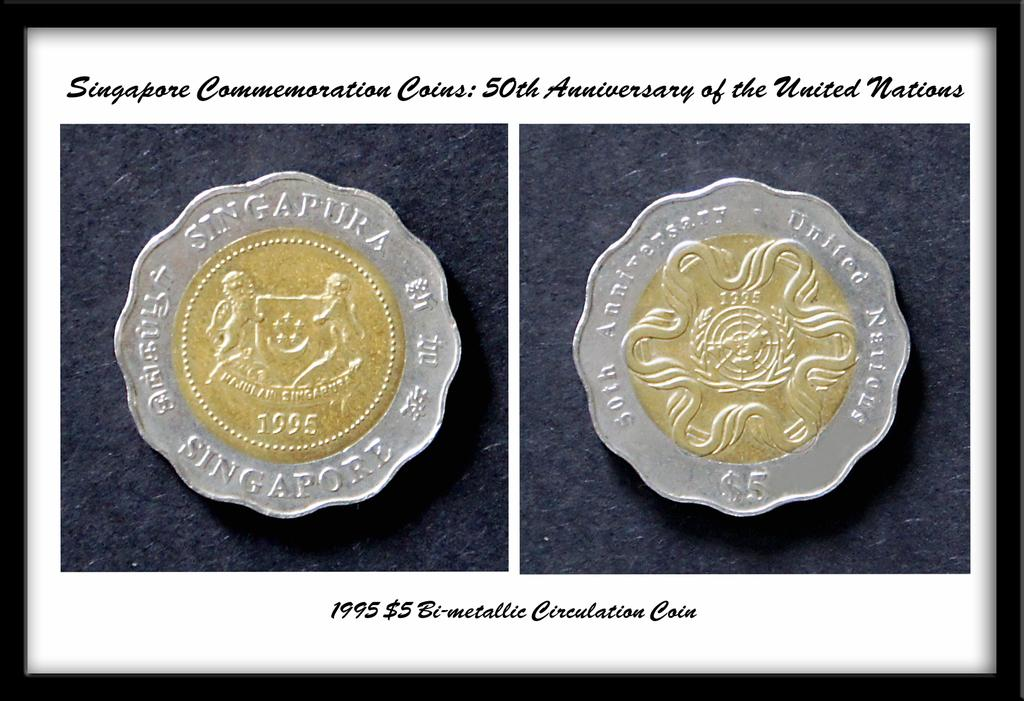<image>
Summarize the visual content of the image. A five singapura coin from Singapore is set on the heads and tails side. 